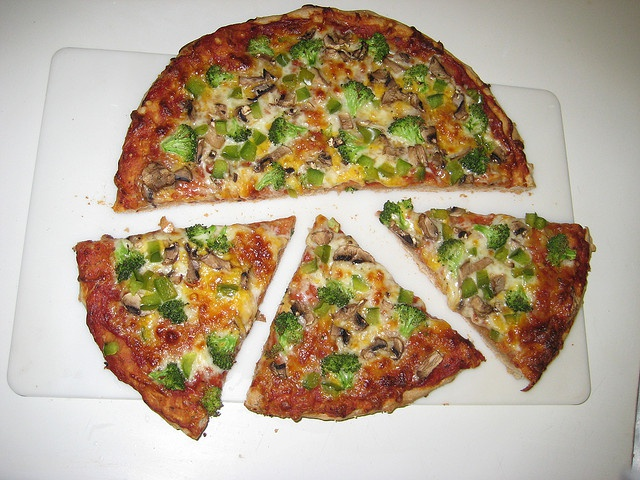Describe the objects in this image and their specific colors. I can see pizza in gray, brown, olive, maroon, and tan tones, pizza in gray, brown, white, and olive tones, pizza in gray, brown, tan, and olive tones, pizza in gray, maroon, olive, tan, and brown tones, and broccoli in gray, olive, and black tones in this image. 